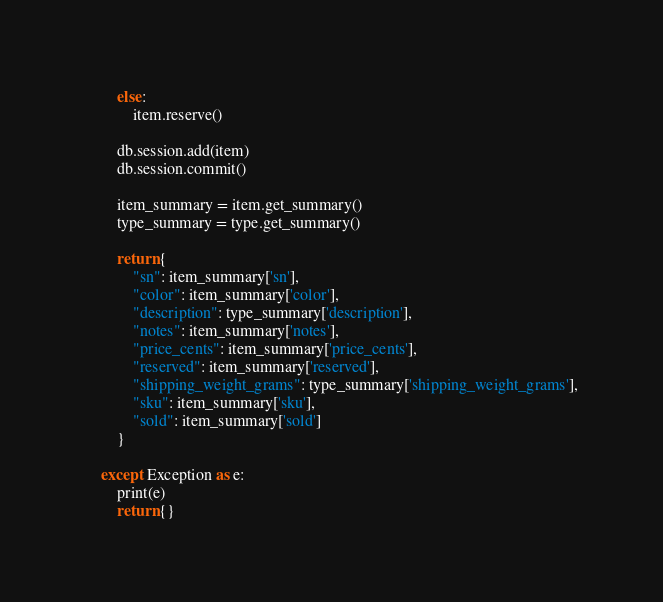Convert code to text. <code><loc_0><loc_0><loc_500><loc_500><_Python_>        else:
            item.reserve()

        db.session.add(item)
        db.session.commit()

        item_summary = item.get_summary()
        type_summary = type.get_summary()

        return {
            "sn": item_summary['sn'],
            "color": item_summary['color'],
            "description": type_summary['description'],
            "notes": item_summary['notes'],
            "price_cents": item_summary['price_cents'],
            "reserved": item_summary['reserved'],
            "shipping_weight_grams": type_summary['shipping_weight_grams'],
            "sku": item_summary['sku'],
            "sold": item_summary['sold']
        }

    except Exception as e:
        print(e)
        return {}
</code> 